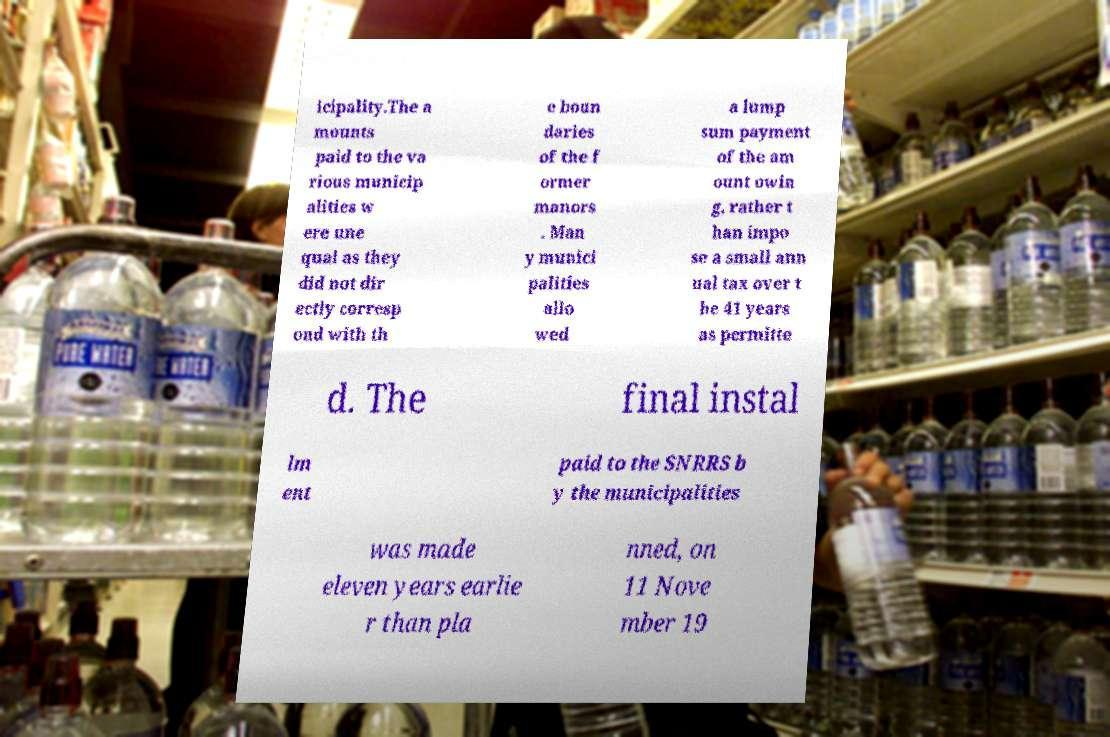There's text embedded in this image that I need extracted. Can you transcribe it verbatim? icipality.The a mounts paid to the va rious municip alities w ere une qual as they did not dir ectly corresp ond with th e boun daries of the f ormer manors . Man y munici palities allo wed a lump sum payment of the am ount owin g, rather t han impo se a small ann ual tax over t he 41 years as permitte d. The final instal lm ent paid to the SNRRS b y the municipalities was made eleven years earlie r than pla nned, on 11 Nove mber 19 